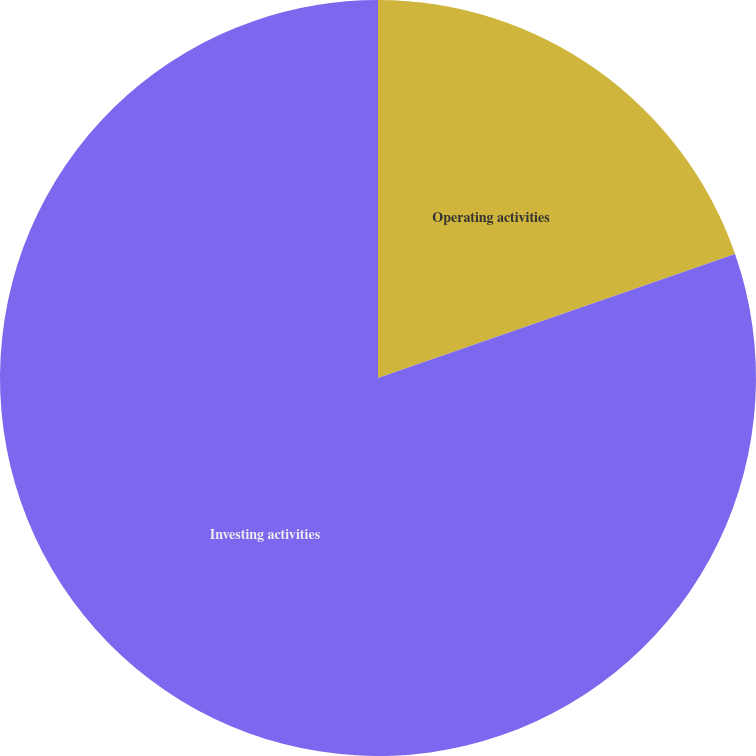Convert chart to OTSL. <chart><loc_0><loc_0><loc_500><loc_500><pie_chart><fcel>Operating activities<fcel>Investing activities<nl><fcel>19.68%<fcel>80.32%<nl></chart> 